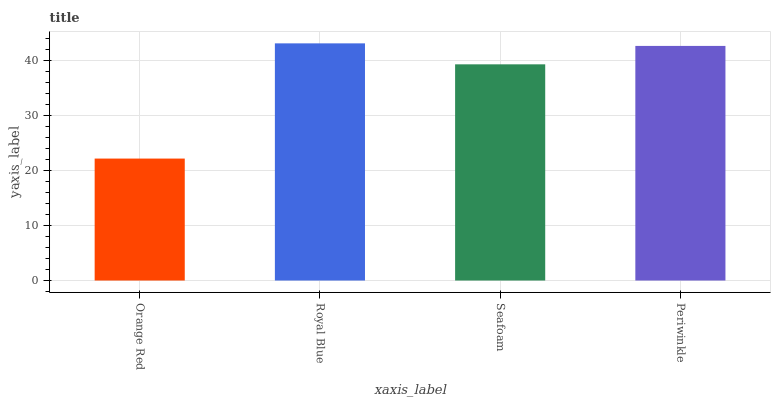Is Orange Red the minimum?
Answer yes or no. Yes. Is Royal Blue the maximum?
Answer yes or no. Yes. Is Seafoam the minimum?
Answer yes or no. No. Is Seafoam the maximum?
Answer yes or no. No. Is Royal Blue greater than Seafoam?
Answer yes or no. Yes. Is Seafoam less than Royal Blue?
Answer yes or no. Yes. Is Seafoam greater than Royal Blue?
Answer yes or no. No. Is Royal Blue less than Seafoam?
Answer yes or no. No. Is Periwinkle the high median?
Answer yes or no. Yes. Is Seafoam the low median?
Answer yes or no. Yes. Is Royal Blue the high median?
Answer yes or no. No. Is Orange Red the low median?
Answer yes or no. No. 